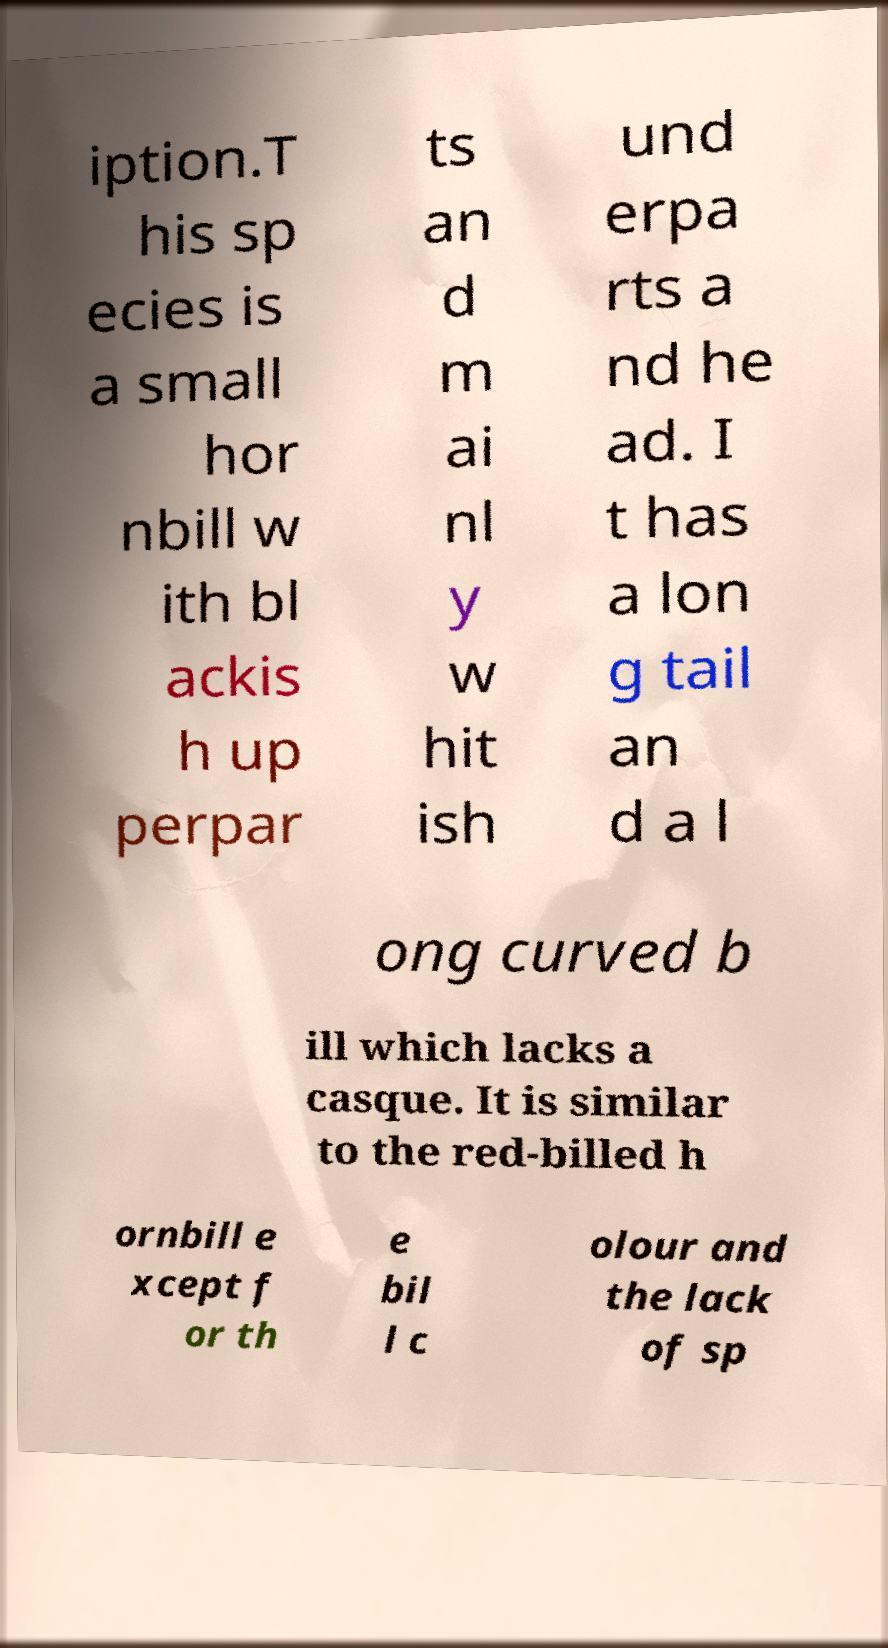What messages or text are displayed in this image? I need them in a readable, typed format. iption.T his sp ecies is a small hor nbill w ith bl ackis h up perpar ts an d m ai nl y w hit ish und erpa rts a nd he ad. I t has a lon g tail an d a l ong curved b ill which lacks a casque. It is similar to the red-billed h ornbill e xcept f or th e bil l c olour and the lack of sp 